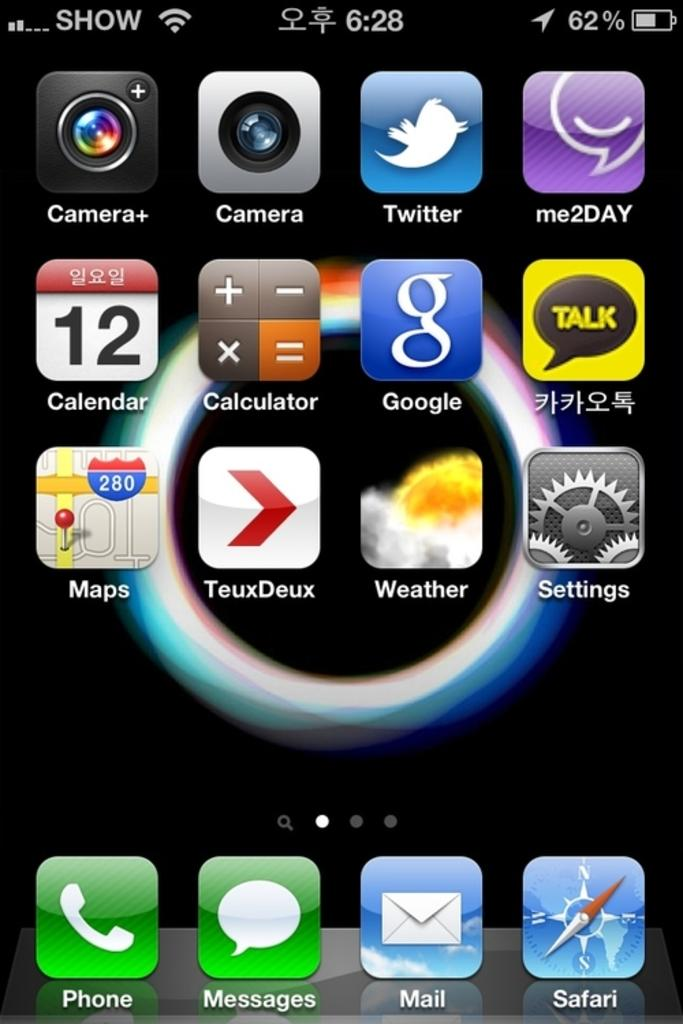<image>
Offer a succinct explanation of the picture presented. The time of the cellphone shows 6:28 with a battery at 62%. 